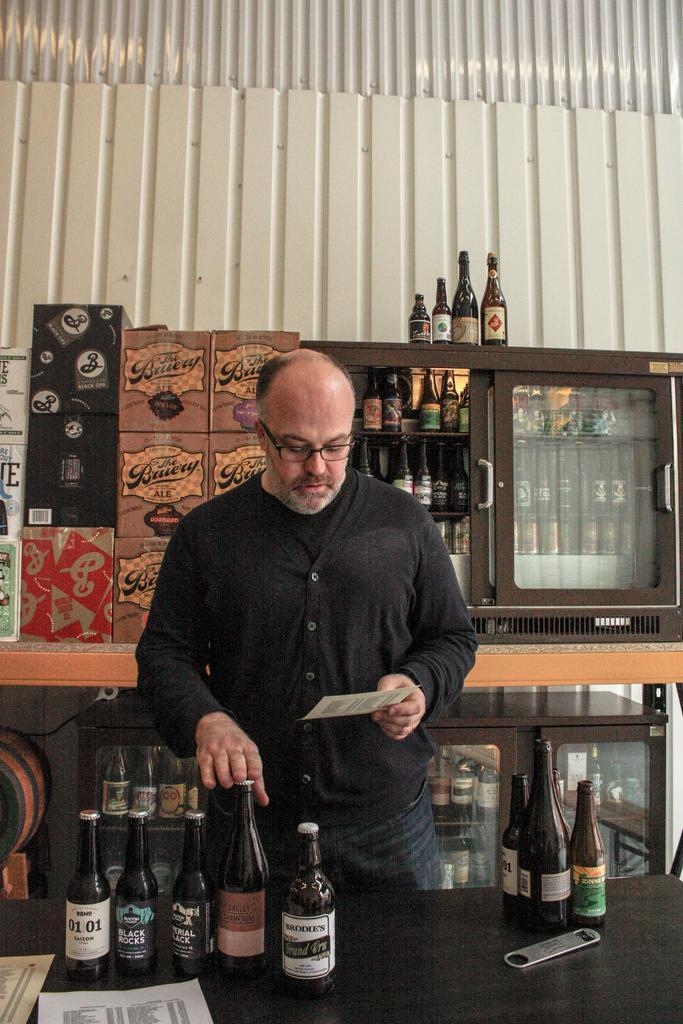Please provide a concise description of this image. At the bottom of the image there is a table with bottles, papers and openers. Behind the table there is a man with spectacles is standing and holding a paper in the hand. Behind him there is a table with cupboards. Inside the cupboards there are bottles and also there are cardboard boxes. In the background there is a wall. 